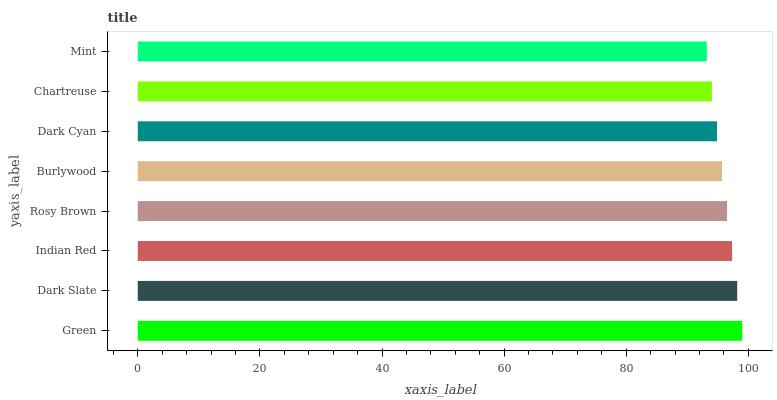Is Mint the minimum?
Answer yes or no. Yes. Is Green the maximum?
Answer yes or no. Yes. Is Dark Slate the minimum?
Answer yes or no. No. Is Dark Slate the maximum?
Answer yes or no. No. Is Green greater than Dark Slate?
Answer yes or no. Yes. Is Dark Slate less than Green?
Answer yes or no. Yes. Is Dark Slate greater than Green?
Answer yes or no. No. Is Green less than Dark Slate?
Answer yes or no. No. Is Rosy Brown the high median?
Answer yes or no. Yes. Is Burlywood the low median?
Answer yes or no. Yes. Is Dark Cyan the high median?
Answer yes or no. No. Is Green the low median?
Answer yes or no. No. 